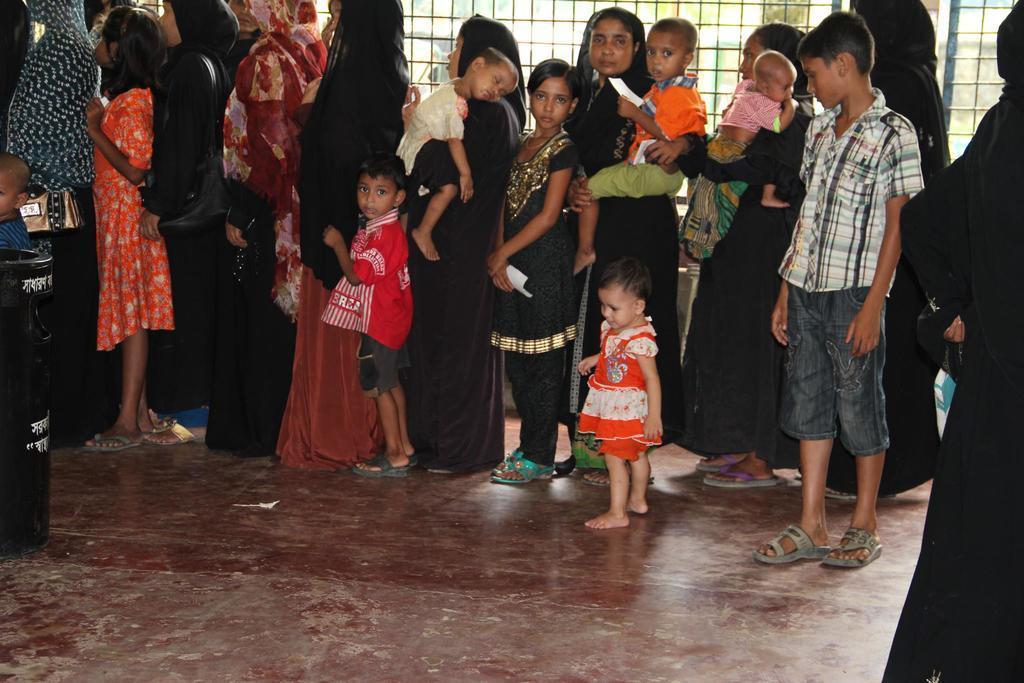Describe this image in one or two sentences. Here people are standing in a line, this is iron fencing. 